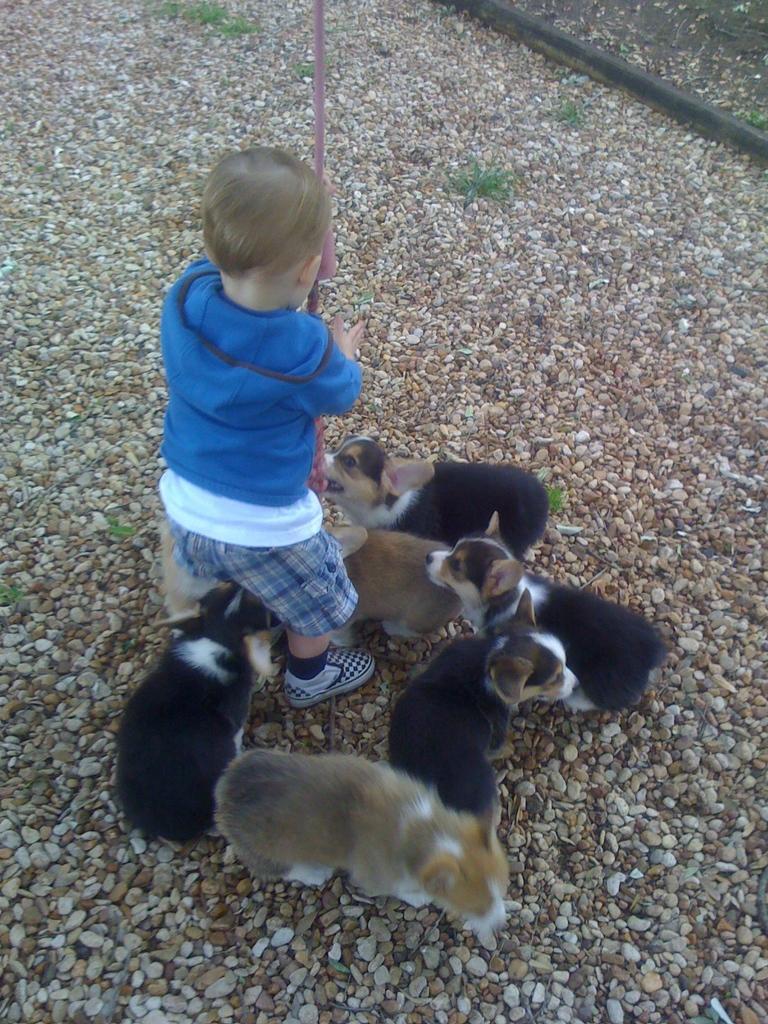Describe this image in one or two sentences. Here I can see a boy wearing blue color t-shirt, short and playing with puppies. This boy is holding a stick in the hands. On the ground, I can see the stones. 